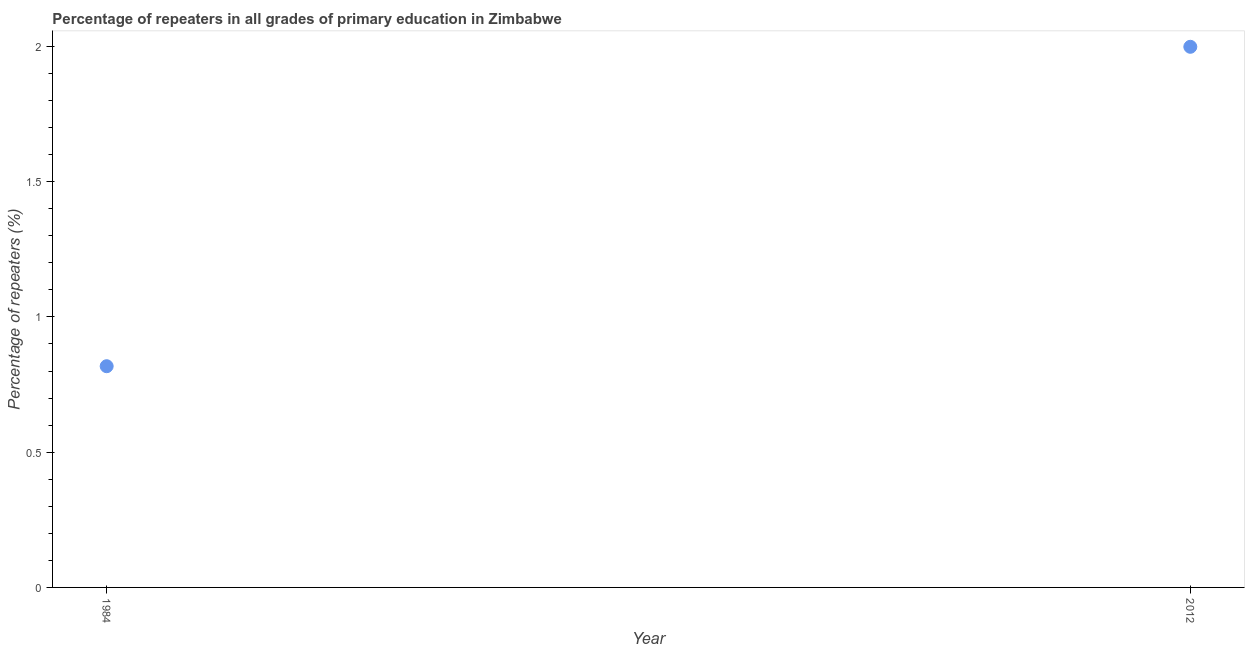What is the percentage of repeaters in primary education in 2012?
Your answer should be very brief. 2. Across all years, what is the maximum percentage of repeaters in primary education?
Make the answer very short. 2. Across all years, what is the minimum percentage of repeaters in primary education?
Provide a short and direct response. 0.82. What is the sum of the percentage of repeaters in primary education?
Ensure brevity in your answer.  2.82. What is the difference between the percentage of repeaters in primary education in 1984 and 2012?
Offer a very short reply. -1.18. What is the average percentage of repeaters in primary education per year?
Make the answer very short. 1.41. What is the median percentage of repeaters in primary education?
Ensure brevity in your answer.  1.41. In how many years, is the percentage of repeaters in primary education greater than 0.5 %?
Ensure brevity in your answer.  2. What is the ratio of the percentage of repeaters in primary education in 1984 to that in 2012?
Give a very brief answer. 0.41. Is the percentage of repeaters in primary education in 1984 less than that in 2012?
Provide a succinct answer. Yes. Does the percentage of repeaters in primary education monotonically increase over the years?
Keep it short and to the point. Yes. How many years are there in the graph?
Make the answer very short. 2. What is the difference between two consecutive major ticks on the Y-axis?
Give a very brief answer. 0.5. Are the values on the major ticks of Y-axis written in scientific E-notation?
Your response must be concise. No. Does the graph contain any zero values?
Keep it short and to the point. No. What is the title of the graph?
Provide a short and direct response. Percentage of repeaters in all grades of primary education in Zimbabwe. What is the label or title of the Y-axis?
Make the answer very short. Percentage of repeaters (%). What is the Percentage of repeaters (%) in 1984?
Give a very brief answer. 0.82. What is the Percentage of repeaters (%) in 2012?
Your response must be concise. 2. What is the difference between the Percentage of repeaters (%) in 1984 and 2012?
Offer a very short reply. -1.18. What is the ratio of the Percentage of repeaters (%) in 1984 to that in 2012?
Ensure brevity in your answer.  0.41. 